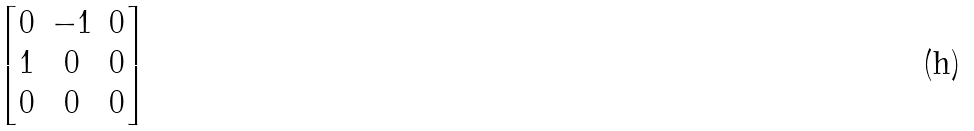Convert formula to latex. <formula><loc_0><loc_0><loc_500><loc_500>\begin{bmatrix} 0 & - 1 & 0 \\ 1 & 0 & 0 \\ 0 & 0 & 0 \end{bmatrix}</formula> 